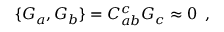<formula> <loc_0><loc_0><loc_500><loc_500>\{ G _ { a } , G _ { b } \} = C _ { a b } ^ { c } G _ { c } \approx 0 \, ,</formula> 